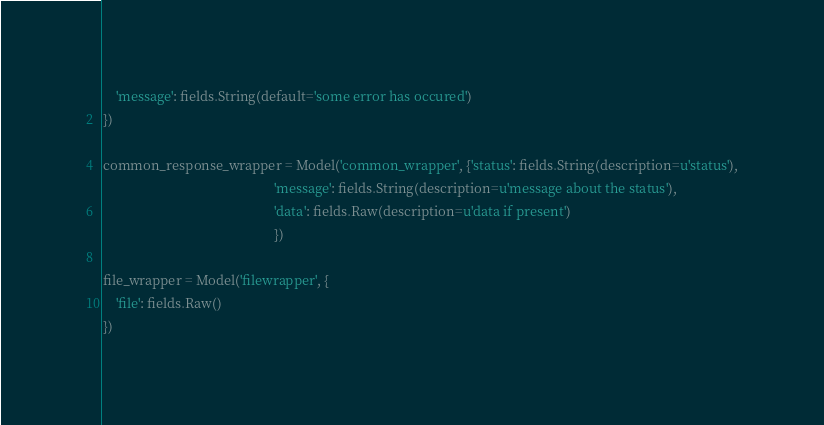<code> <loc_0><loc_0><loc_500><loc_500><_Python_>    'message': fields.String(default='some error has occured')
})

common_response_wrapper = Model('common_wrapper', {'status': fields.String(description=u'status'),
                                                   'message': fields.String(description=u'message about the status'),
                                                   'data': fields.Raw(description=u'data if present')
                                                   })

file_wrapper = Model('filewrapper', {
    'file': fields.Raw()
})</code> 